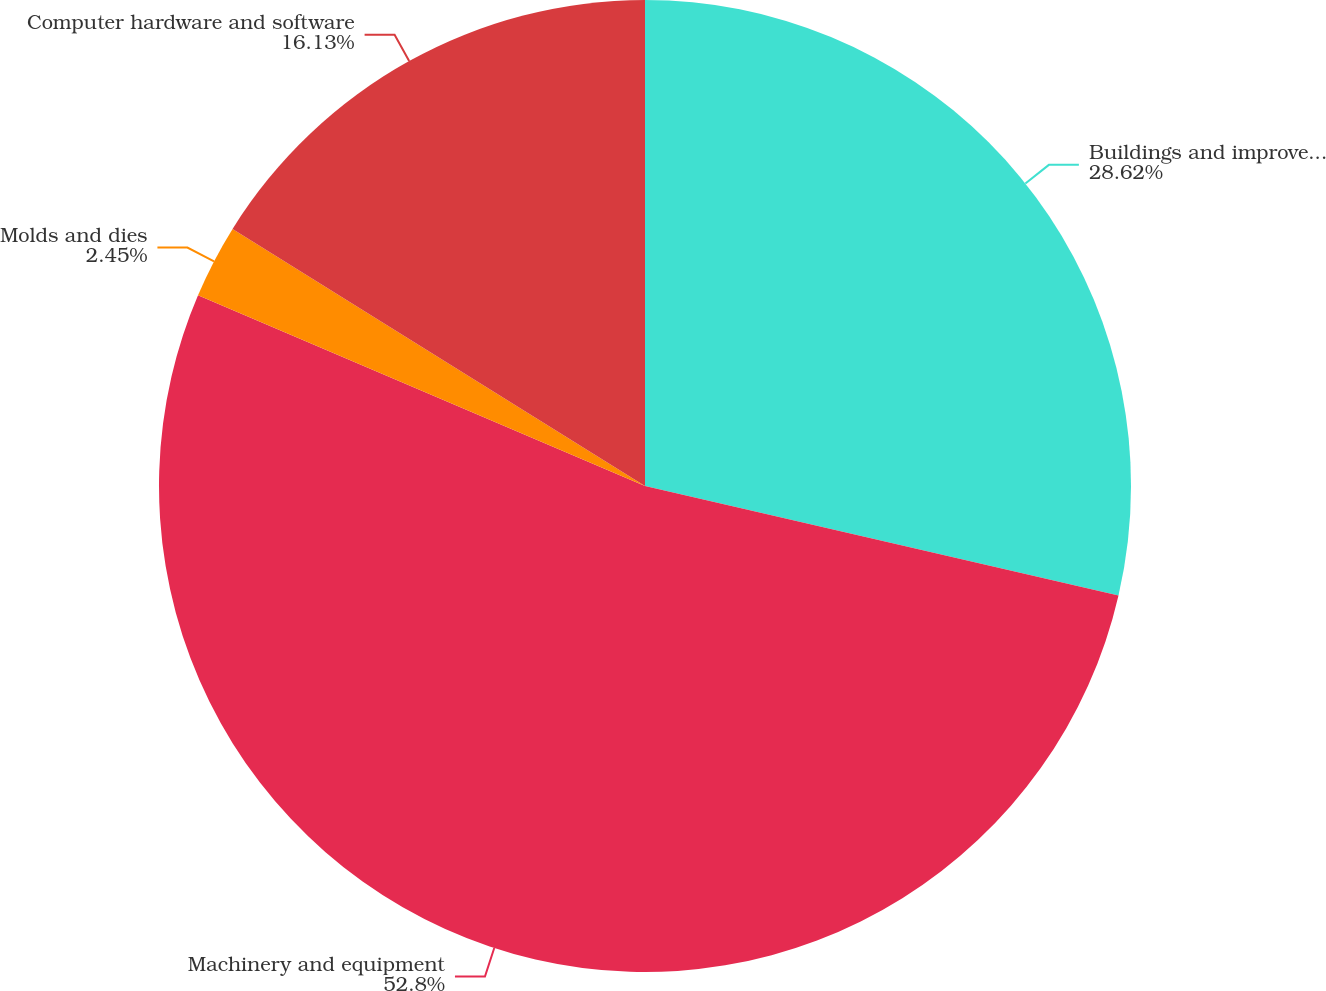Convert chart to OTSL. <chart><loc_0><loc_0><loc_500><loc_500><pie_chart><fcel>Buildings and improvements<fcel>Machinery and equipment<fcel>Molds and dies<fcel>Computer hardware and software<nl><fcel>28.62%<fcel>52.81%<fcel>2.45%<fcel>16.13%<nl></chart> 